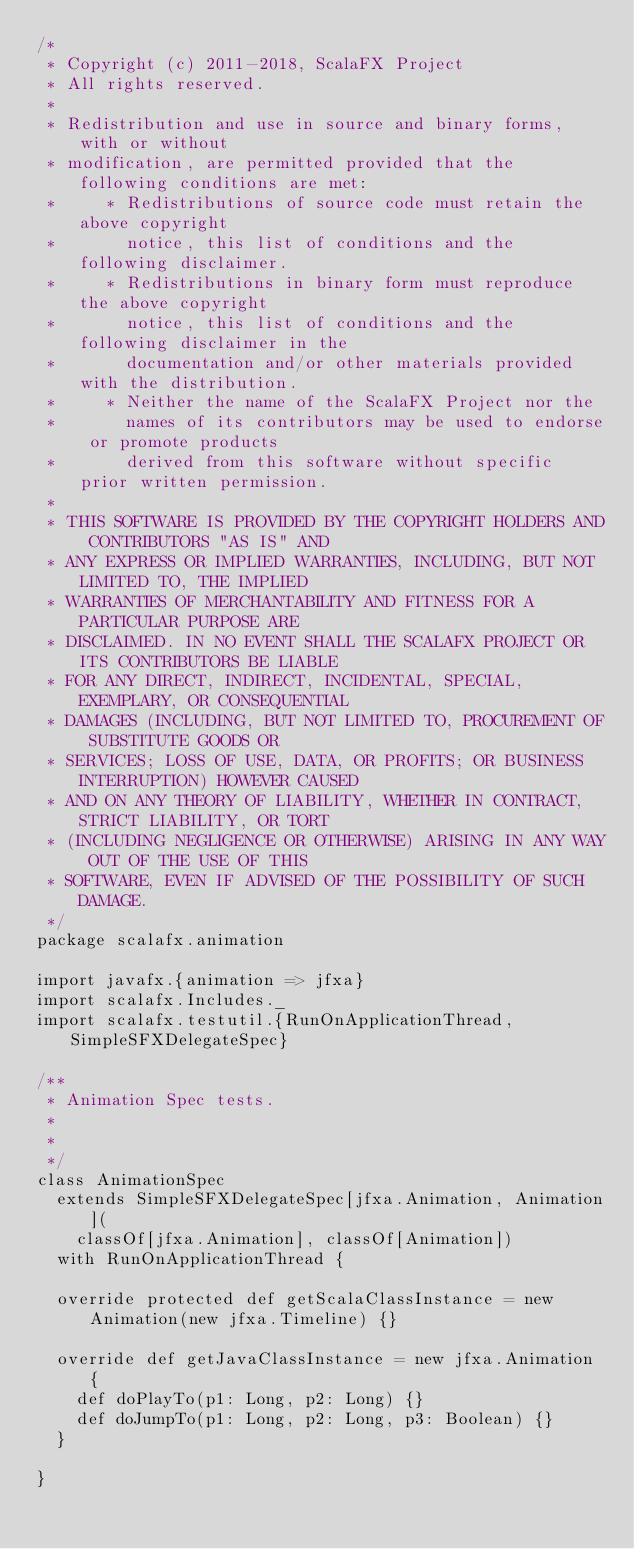Convert code to text. <code><loc_0><loc_0><loc_500><loc_500><_Scala_>/*
 * Copyright (c) 2011-2018, ScalaFX Project
 * All rights reserved.
 *
 * Redistribution and use in source and binary forms, with or without
 * modification, are permitted provided that the following conditions are met:
 *     * Redistributions of source code must retain the above copyright
 *       notice, this list of conditions and the following disclaimer.
 *     * Redistributions in binary form must reproduce the above copyright
 *       notice, this list of conditions and the following disclaimer in the
 *       documentation and/or other materials provided with the distribution.
 *     * Neither the name of the ScalaFX Project nor the
 *       names of its contributors may be used to endorse or promote products
 *       derived from this software without specific prior written permission.
 *
 * THIS SOFTWARE IS PROVIDED BY THE COPYRIGHT HOLDERS AND CONTRIBUTORS "AS IS" AND
 * ANY EXPRESS OR IMPLIED WARRANTIES, INCLUDING, BUT NOT LIMITED TO, THE IMPLIED
 * WARRANTIES OF MERCHANTABILITY AND FITNESS FOR A PARTICULAR PURPOSE ARE
 * DISCLAIMED. IN NO EVENT SHALL THE SCALAFX PROJECT OR ITS CONTRIBUTORS BE LIABLE
 * FOR ANY DIRECT, INDIRECT, INCIDENTAL, SPECIAL, EXEMPLARY, OR CONSEQUENTIAL
 * DAMAGES (INCLUDING, BUT NOT LIMITED TO, PROCUREMENT OF SUBSTITUTE GOODS OR
 * SERVICES; LOSS OF USE, DATA, OR PROFITS; OR BUSINESS INTERRUPTION) HOWEVER CAUSED
 * AND ON ANY THEORY OF LIABILITY, WHETHER IN CONTRACT, STRICT LIABILITY, OR TORT
 * (INCLUDING NEGLIGENCE OR OTHERWISE) ARISING IN ANY WAY OUT OF THE USE OF THIS
 * SOFTWARE, EVEN IF ADVISED OF THE POSSIBILITY OF SUCH DAMAGE.
 */
package scalafx.animation

import javafx.{animation => jfxa}
import scalafx.Includes._
import scalafx.testutil.{RunOnApplicationThread, SimpleSFXDelegateSpec}

/**
 * Animation Spec tests.
 *
 *
 */
class AnimationSpec
  extends SimpleSFXDelegateSpec[jfxa.Animation, Animation](
    classOf[jfxa.Animation], classOf[Animation])
  with RunOnApplicationThread {

  override protected def getScalaClassInstance = new Animation(new jfxa.Timeline) {}

  override def getJavaClassInstance = new jfxa.Animation {
    def doPlayTo(p1: Long, p2: Long) {}
    def doJumpTo(p1: Long, p2: Long, p3: Boolean) {}
  }

}</code> 